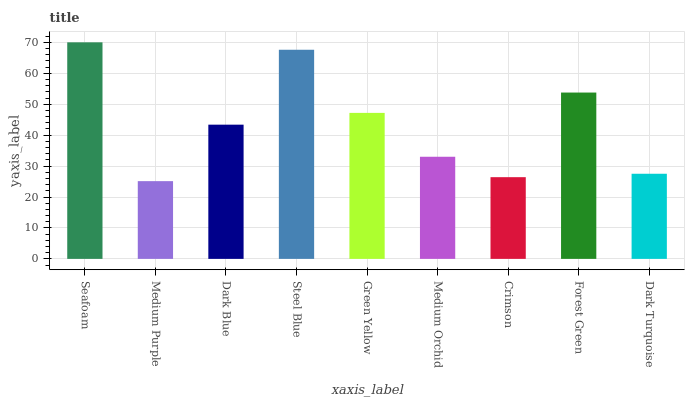Is Medium Purple the minimum?
Answer yes or no. Yes. Is Seafoam the maximum?
Answer yes or no. Yes. Is Dark Blue the minimum?
Answer yes or no. No. Is Dark Blue the maximum?
Answer yes or no. No. Is Dark Blue greater than Medium Purple?
Answer yes or no. Yes. Is Medium Purple less than Dark Blue?
Answer yes or no. Yes. Is Medium Purple greater than Dark Blue?
Answer yes or no. No. Is Dark Blue less than Medium Purple?
Answer yes or no. No. Is Dark Blue the high median?
Answer yes or no. Yes. Is Dark Blue the low median?
Answer yes or no. Yes. Is Medium Purple the high median?
Answer yes or no. No. Is Medium Orchid the low median?
Answer yes or no. No. 